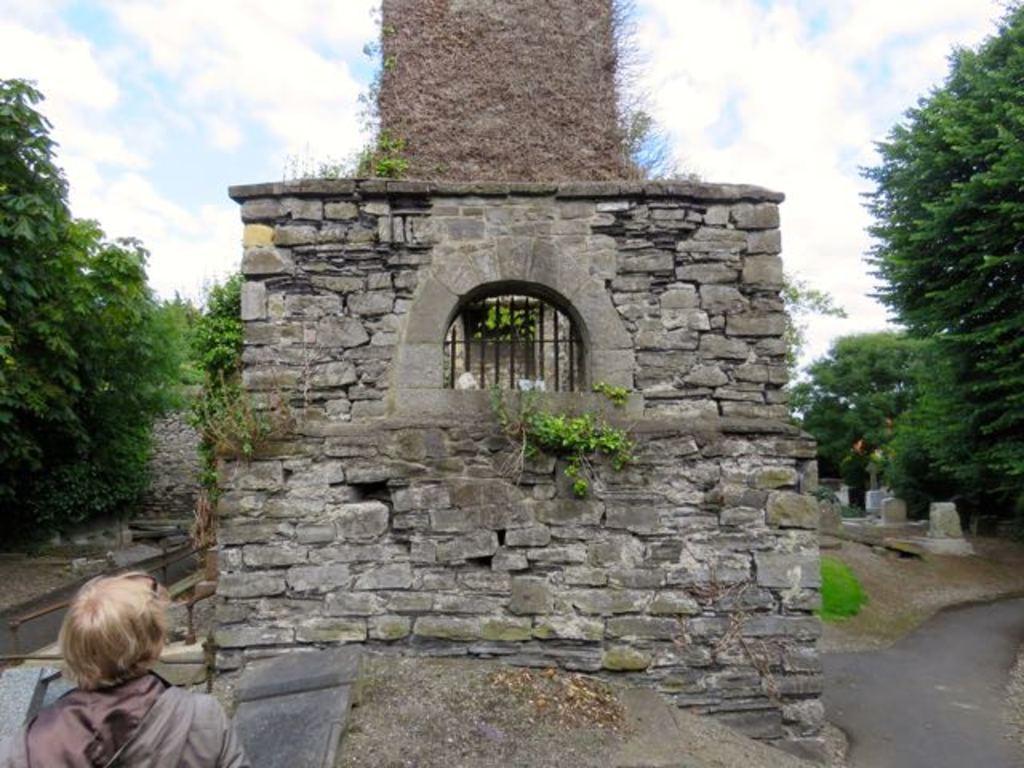Can you describe this image briefly? In front of the image there is a person, the person is looking at a rock wall in front of him, on the either side of the wall there are trees and headstones, in the background of the image there is a rock wall, at the top of the image there are clouds in the sky. 